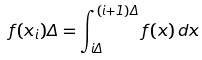Convert formula to latex. <formula><loc_0><loc_0><loc_500><loc_500>f ( x _ { i } ) \Delta = \int _ { i \Delta } ^ { ( i + 1 ) \Delta } f ( x ) \, d x</formula> 